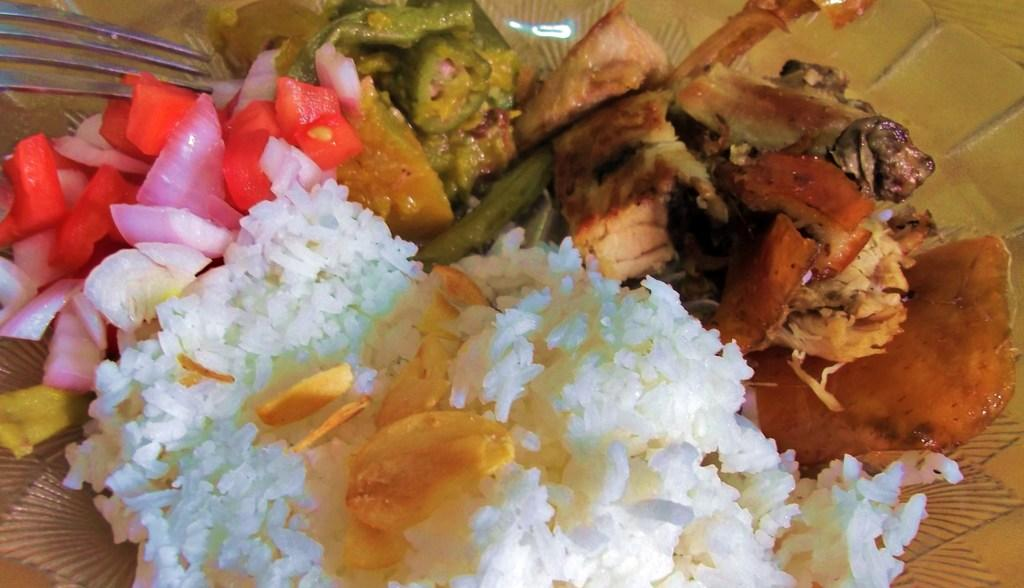What is on the plate that is visible in the image? The plate contains food items. What utensil is present in the image? There is a fork in the image. How many pigs are visible in the image? There are no pigs present in the image. What type of visitor can be seen interacting with the food on the plate? There is no visitor present in the image; it only shows a plate with food items and a fork. 